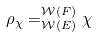<formula> <loc_0><loc_0><loc_500><loc_500>\rho _ { \chi } = _ { \mathcal { W } ( E ) } ^ { \mathcal { W } ( F ) } \chi</formula> 